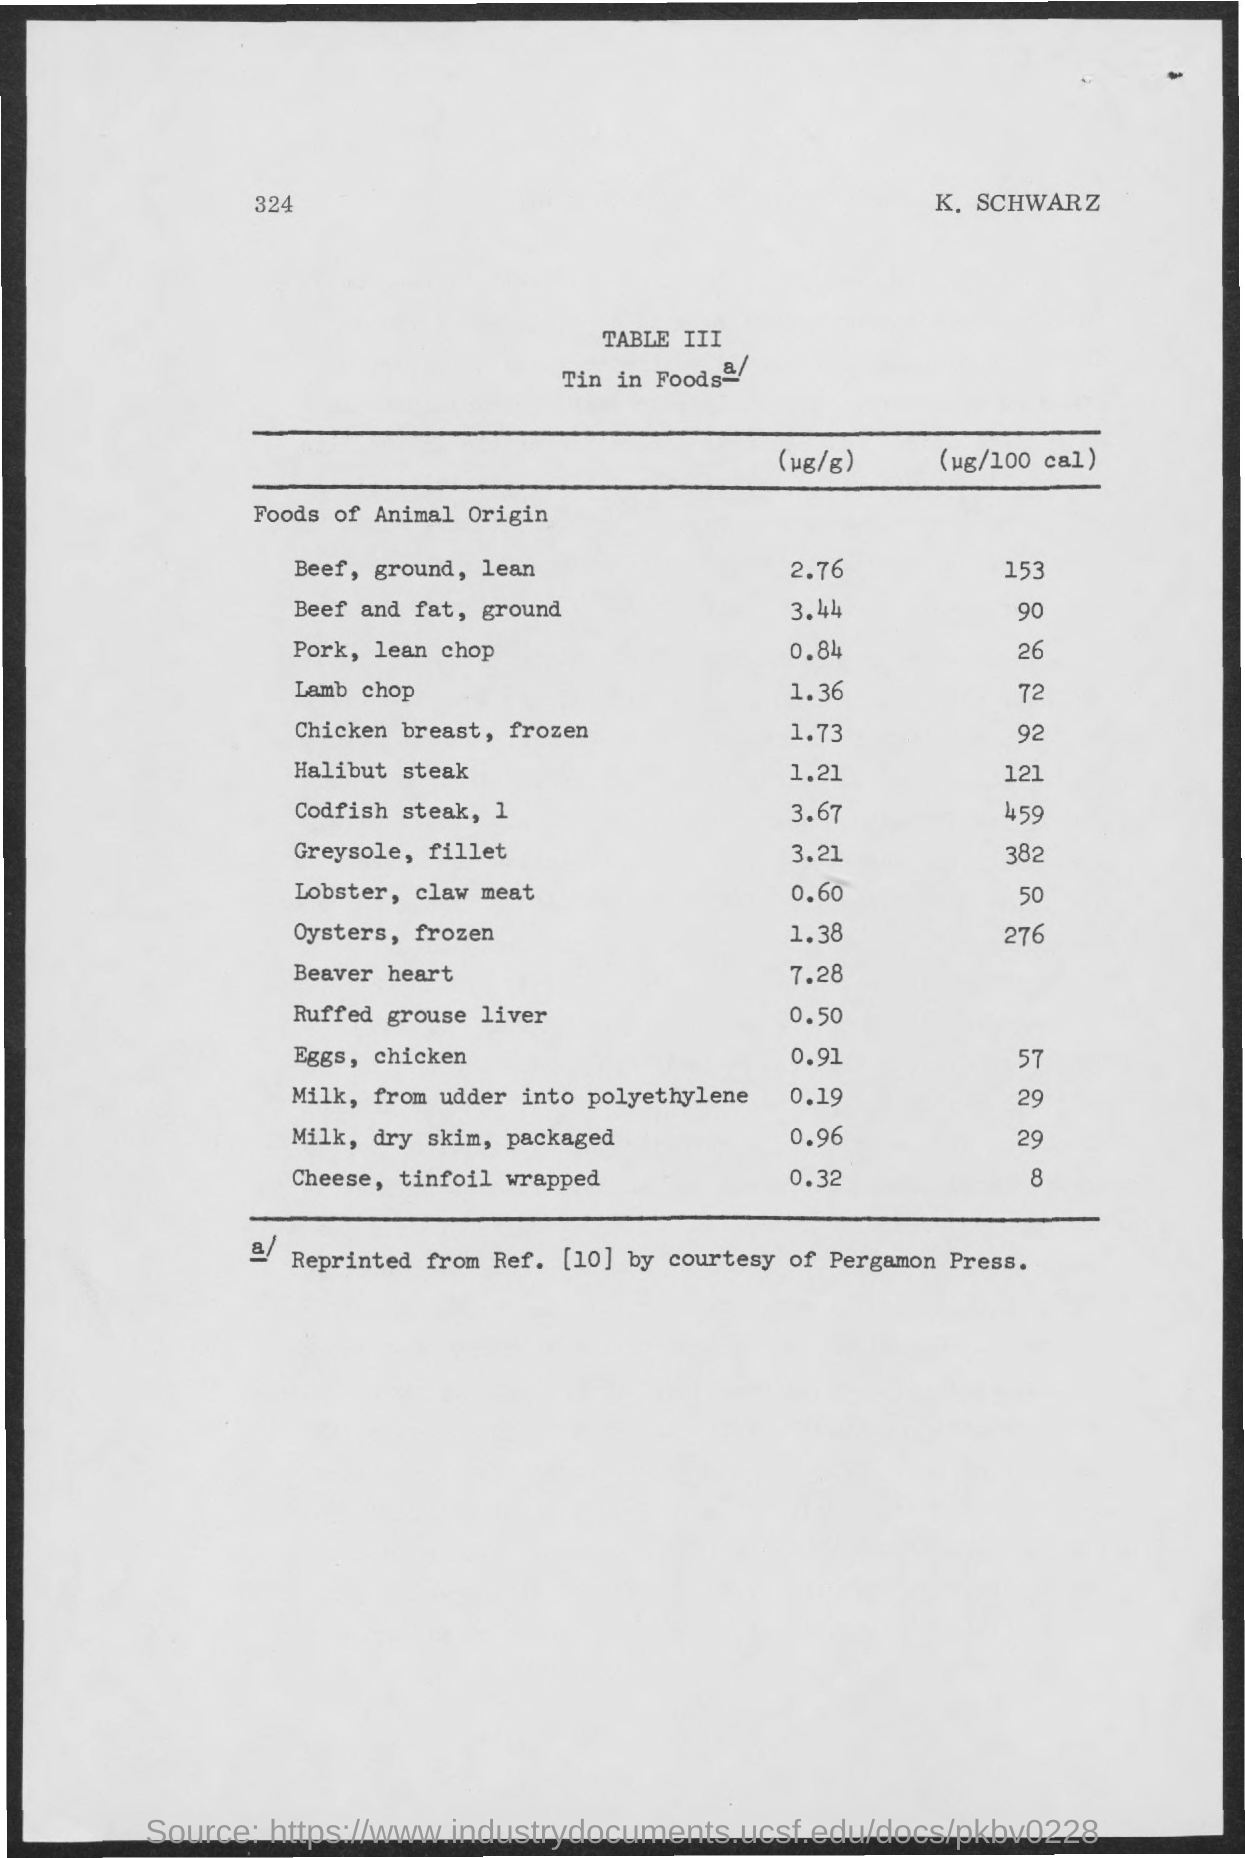What is the number mentioned  on the top left side of the page
Offer a very short reply. 324. What is the name mentioned on the top right side of the page
Offer a very short reply. K. schwarz. What is the table no. mentioned in the given page ?
Offer a very short reply. Table iii. What is the title of the table
Give a very brief answer. Tin in foods. How much amount of beef, ground , lean in '( ug/g) is mentioned ?
Your answer should be compact. 2.76. 